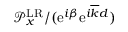Convert formula to latex. <formula><loc_0><loc_0><loc_500><loc_500>{ \mathcal { P } } _ { x } ^ { L R } / ( e ^ { i \beta } e ^ { i \overline { k } d } )</formula> 